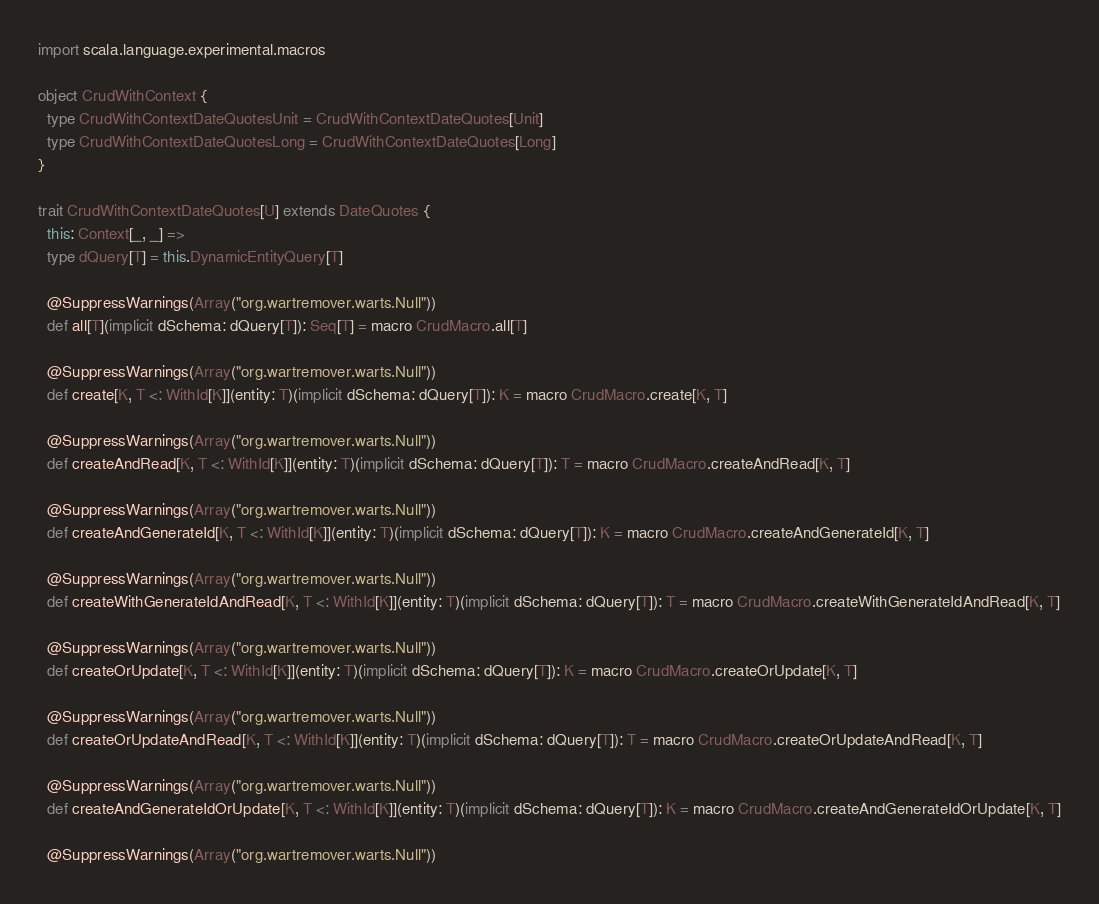Convert code to text. <code><loc_0><loc_0><loc_500><loc_500><_Scala_>
import scala.language.experimental.macros

object CrudWithContext {
  type CrudWithContextDateQuotesUnit = CrudWithContextDateQuotes[Unit]
  type CrudWithContextDateQuotesLong = CrudWithContextDateQuotes[Long]
}

trait CrudWithContextDateQuotes[U] extends DateQuotes {
  this: Context[_, _] =>
  type dQuery[T] = this.DynamicEntityQuery[T]

  @SuppressWarnings(Array("org.wartremover.warts.Null"))
  def all[T](implicit dSchema: dQuery[T]): Seq[T] = macro CrudMacro.all[T]

  @SuppressWarnings(Array("org.wartremover.warts.Null"))
  def create[K, T <: WithId[K]](entity: T)(implicit dSchema: dQuery[T]): K = macro CrudMacro.create[K, T]

  @SuppressWarnings(Array("org.wartremover.warts.Null"))
  def createAndRead[K, T <: WithId[K]](entity: T)(implicit dSchema: dQuery[T]): T = macro CrudMacro.createAndRead[K, T]

  @SuppressWarnings(Array("org.wartremover.warts.Null"))
  def createAndGenerateId[K, T <: WithId[K]](entity: T)(implicit dSchema: dQuery[T]): K = macro CrudMacro.createAndGenerateId[K, T]

  @SuppressWarnings(Array("org.wartremover.warts.Null"))
  def createWithGenerateIdAndRead[K, T <: WithId[K]](entity: T)(implicit dSchema: dQuery[T]): T = macro CrudMacro.createWithGenerateIdAndRead[K, T]

  @SuppressWarnings(Array("org.wartremover.warts.Null"))
  def createOrUpdate[K, T <: WithId[K]](entity: T)(implicit dSchema: dQuery[T]): K = macro CrudMacro.createOrUpdate[K, T]

  @SuppressWarnings(Array("org.wartremover.warts.Null"))
  def createOrUpdateAndRead[K, T <: WithId[K]](entity: T)(implicit dSchema: dQuery[T]): T = macro CrudMacro.createOrUpdateAndRead[K, T]

  @SuppressWarnings(Array("org.wartremover.warts.Null"))
  def createAndGenerateIdOrUpdate[K, T <: WithId[K]](entity: T)(implicit dSchema: dQuery[T]): K = macro CrudMacro.createAndGenerateIdOrUpdate[K, T]

  @SuppressWarnings(Array("org.wartremover.warts.Null"))</code> 